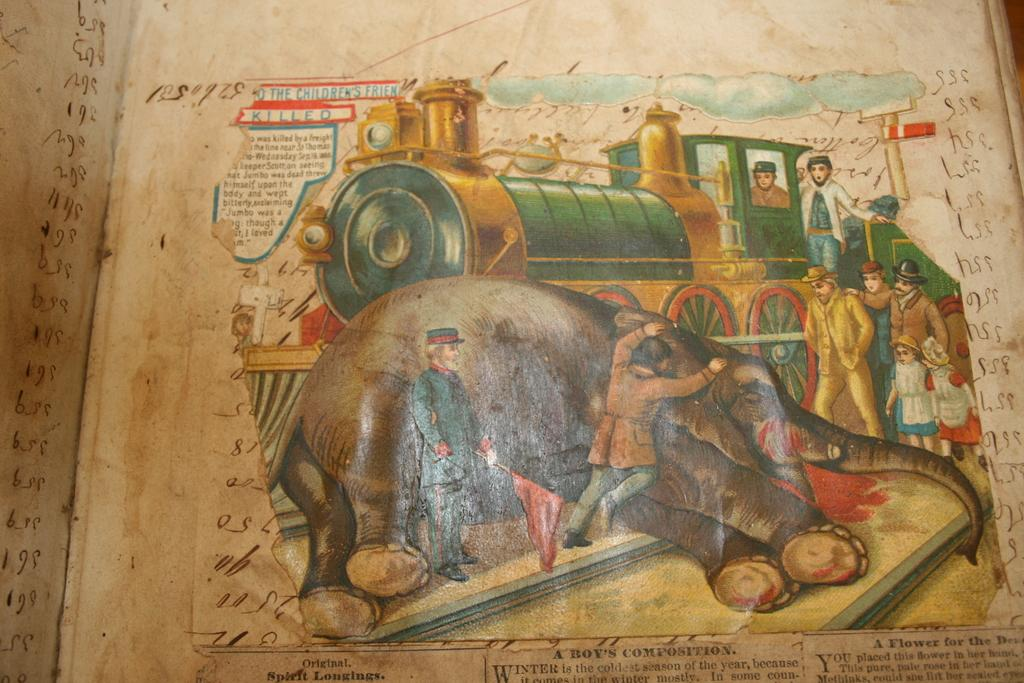<image>
Share a concise interpretation of the image provided. a paper that says 'killed' at the top of it 